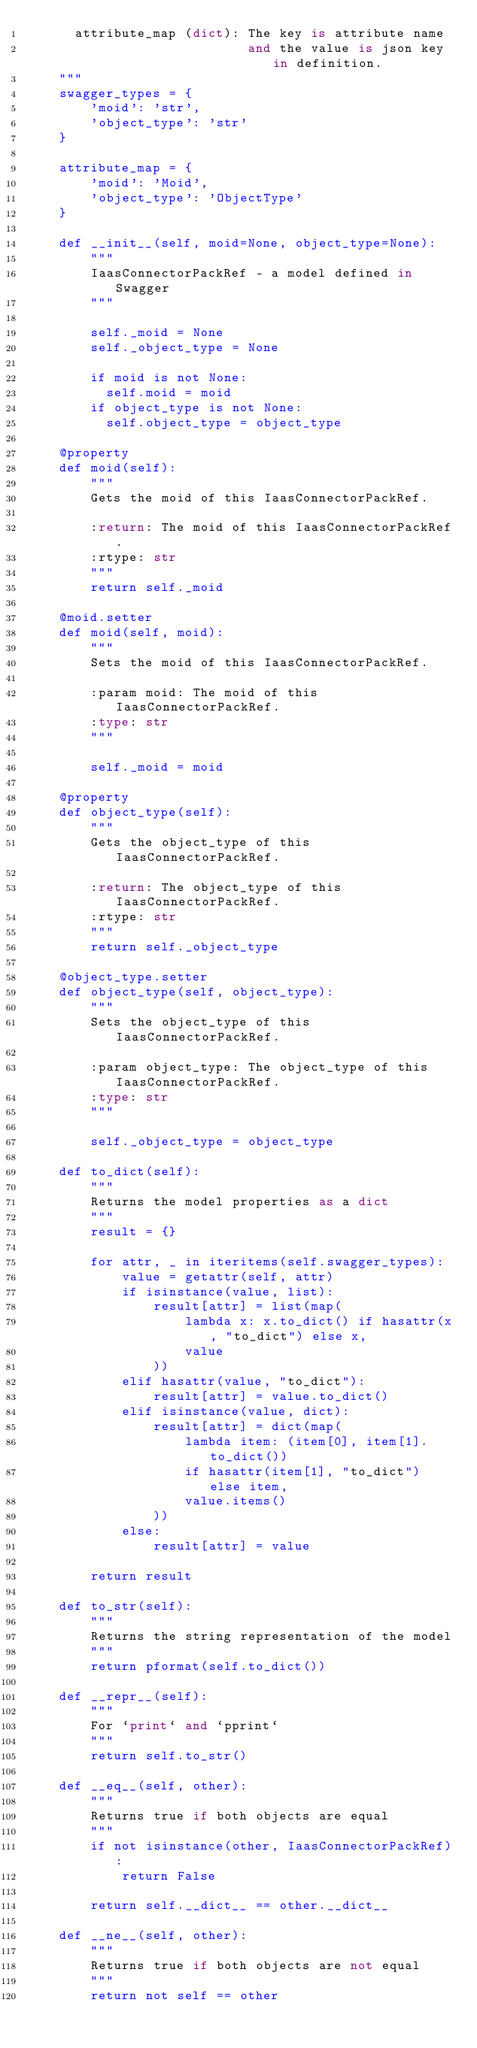Convert code to text. <code><loc_0><loc_0><loc_500><loc_500><_Python_>      attribute_map (dict): The key is attribute name
                            and the value is json key in definition.
    """
    swagger_types = {
        'moid': 'str',
        'object_type': 'str'
    }

    attribute_map = {
        'moid': 'Moid',
        'object_type': 'ObjectType'
    }

    def __init__(self, moid=None, object_type=None):
        """
        IaasConnectorPackRef - a model defined in Swagger
        """

        self._moid = None
        self._object_type = None

        if moid is not None:
          self.moid = moid
        if object_type is not None:
          self.object_type = object_type

    @property
    def moid(self):
        """
        Gets the moid of this IaasConnectorPackRef.

        :return: The moid of this IaasConnectorPackRef.
        :rtype: str
        """
        return self._moid

    @moid.setter
    def moid(self, moid):
        """
        Sets the moid of this IaasConnectorPackRef.

        :param moid: The moid of this IaasConnectorPackRef.
        :type: str
        """

        self._moid = moid

    @property
    def object_type(self):
        """
        Gets the object_type of this IaasConnectorPackRef.

        :return: The object_type of this IaasConnectorPackRef.
        :rtype: str
        """
        return self._object_type

    @object_type.setter
    def object_type(self, object_type):
        """
        Sets the object_type of this IaasConnectorPackRef.

        :param object_type: The object_type of this IaasConnectorPackRef.
        :type: str
        """

        self._object_type = object_type

    def to_dict(self):
        """
        Returns the model properties as a dict
        """
        result = {}

        for attr, _ in iteritems(self.swagger_types):
            value = getattr(self, attr)
            if isinstance(value, list):
                result[attr] = list(map(
                    lambda x: x.to_dict() if hasattr(x, "to_dict") else x,
                    value
                ))
            elif hasattr(value, "to_dict"):
                result[attr] = value.to_dict()
            elif isinstance(value, dict):
                result[attr] = dict(map(
                    lambda item: (item[0], item[1].to_dict())
                    if hasattr(item[1], "to_dict") else item,
                    value.items()
                ))
            else:
                result[attr] = value

        return result

    def to_str(self):
        """
        Returns the string representation of the model
        """
        return pformat(self.to_dict())

    def __repr__(self):
        """
        For `print` and `pprint`
        """
        return self.to_str()

    def __eq__(self, other):
        """
        Returns true if both objects are equal
        """
        if not isinstance(other, IaasConnectorPackRef):
            return False

        return self.__dict__ == other.__dict__

    def __ne__(self, other):
        """
        Returns true if both objects are not equal
        """
        return not self == other
</code> 